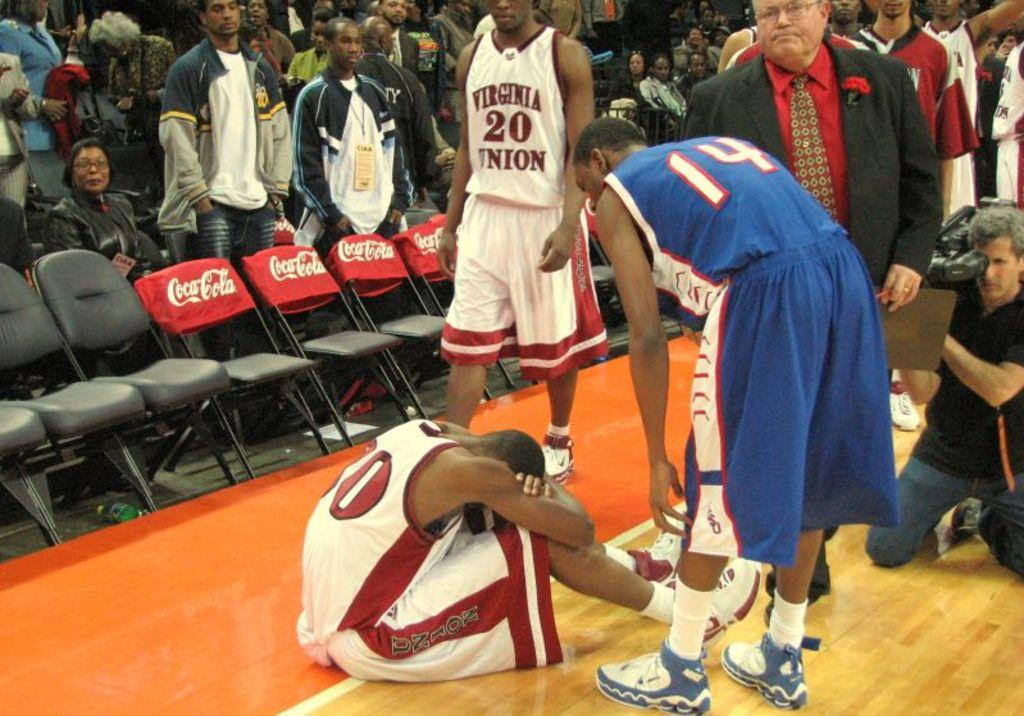<image>
Give a short and clear explanation of the subsequent image. A Virginia Union player sits on the floor of the basketball court in front of ads for Coca Cola. 